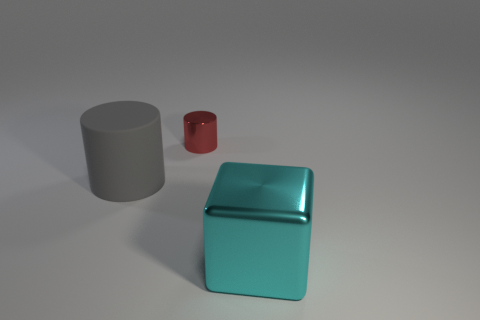Is there any other thing that has the same size as the red metallic cylinder?
Your response must be concise. No. There is a big thing that is left of the big thing in front of the gray cylinder in front of the tiny shiny cylinder; what shape is it?
Give a very brief answer. Cylinder. What is the material of the cylinder that is to the left of the tiny cylinder?
Give a very brief answer. Rubber. What is the color of the shiny thing that is the same size as the matte cylinder?
Keep it short and to the point. Cyan. What number of other things are the same shape as the big cyan thing?
Provide a short and direct response. 0. Is the size of the gray matte object the same as the cyan cube?
Your response must be concise. Yes. Is the number of small red metal cylinders that are in front of the gray thing greater than the number of large matte cylinders that are behind the cyan metal object?
Your answer should be compact. No. How many other things are the same size as the red metal thing?
Your answer should be very brief. 0. Is the color of the big thing that is in front of the gray object the same as the matte thing?
Provide a short and direct response. No. Is the number of tiny red objects on the left side of the large gray thing greater than the number of large gray matte spheres?
Your answer should be compact. No. 